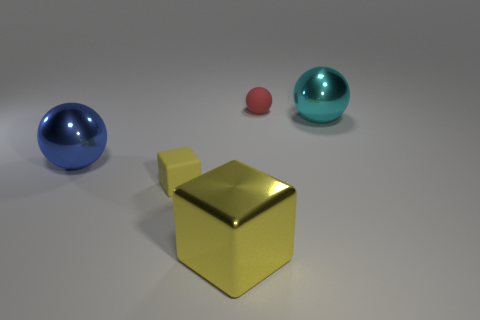What is the shape of the tiny object that is in front of the red thing?
Keep it short and to the point. Cube. What number of other objects are there of the same size as the yellow shiny block?
Make the answer very short. 2. Do the matte object left of the small ball and the small thing that is behind the cyan object have the same shape?
Provide a succinct answer. No. There is a tiny yellow thing; what number of big cyan shiny things are to the right of it?
Keep it short and to the point. 1. There is a big ball that is left of the yellow matte block; what is its color?
Ensure brevity in your answer.  Blue. The other big metallic thing that is the same shape as the blue object is what color?
Ensure brevity in your answer.  Cyan. Are there any other things that are the same color as the big metal block?
Your response must be concise. Yes. Is the number of tiny rubber blocks greater than the number of balls?
Keep it short and to the point. No. Do the large blue sphere and the tiny red ball have the same material?
Your response must be concise. No. What number of big blue things have the same material as the big yellow cube?
Make the answer very short. 1. 